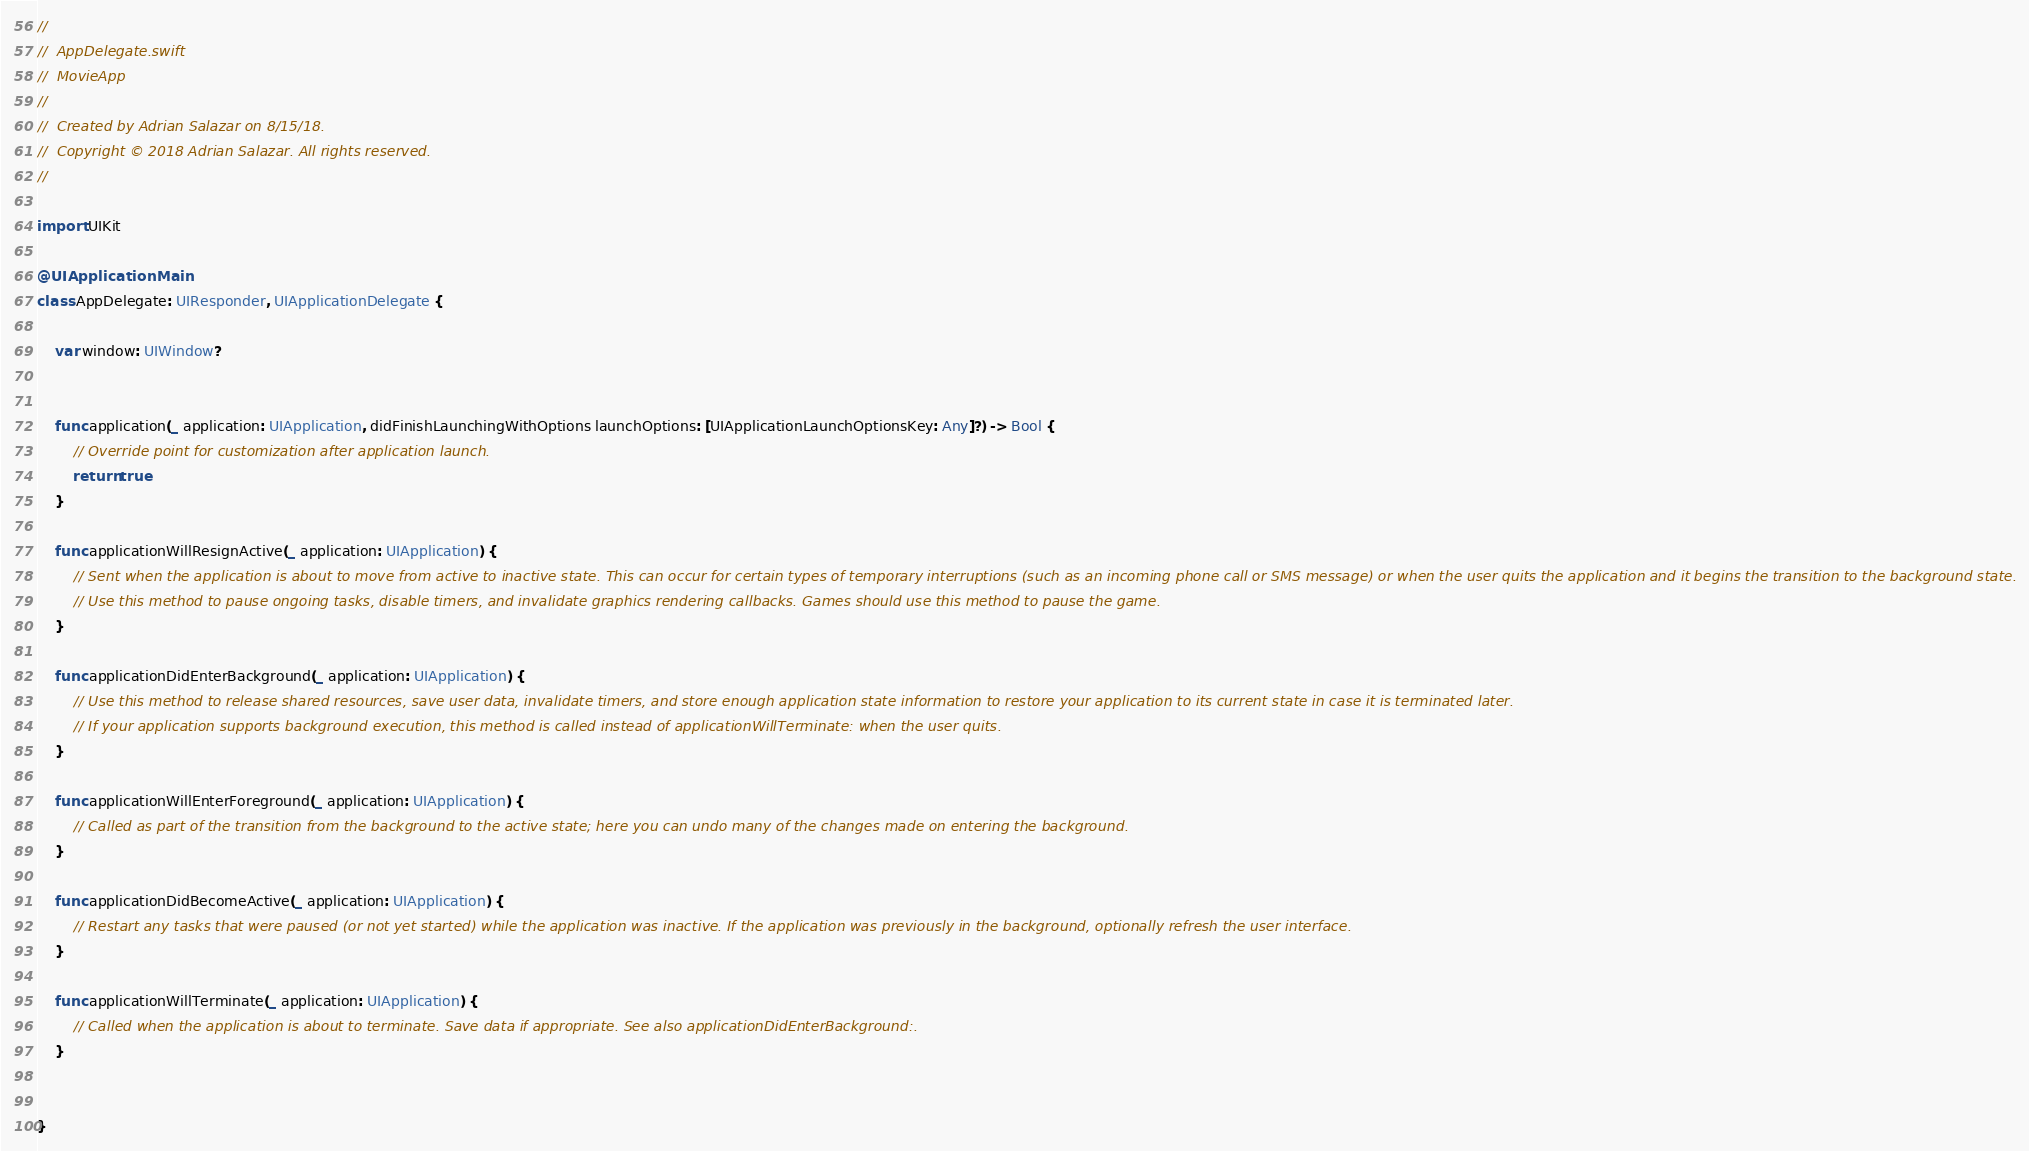Convert code to text. <code><loc_0><loc_0><loc_500><loc_500><_Swift_>//
//  AppDelegate.swift
//  MovieApp
//
//  Created by Adrian Salazar on 8/15/18.
//  Copyright © 2018 Adrian Salazar. All rights reserved.
//

import UIKit

@UIApplicationMain
class AppDelegate: UIResponder, UIApplicationDelegate {

    var window: UIWindow?


    func application(_ application: UIApplication, didFinishLaunchingWithOptions launchOptions: [UIApplicationLaunchOptionsKey: Any]?) -> Bool {
        // Override point for customization after application launch.
        return true
    }

    func applicationWillResignActive(_ application: UIApplication) {
        // Sent when the application is about to move from active to inactive state. This can occur for certain types of temporary interruptions (such as an incoming phone call or SMS message) or when the user quits the application and it begins the transition to the background state.
        // Use this method to pause ongoing tasks, disable timers, and invalidate graphics rendering callbacks. Games should use this method to pause the game.
    }

    func applicationDidEnterBackground(_ application: UIApplication) {
        // Use this method to release shared resources, save user data, invalidate timers, and store enough application state information to restore your application to its current state in case it is terminated later.
        // If your application supports background execution, this method is called instead of applicationWillTerminate: when the user quits.
    }

    func applicationWillEnterForeground(_ application: UIApplication) {
        // Called as part of the transition from the background to the active state; here you can undo many of the changes made on entering the background.
    }

    func applicationDidBecomeActive(_ application: UIApplication) {
        // Restart any tasks that were paused (or not yet started) while the application was inactive. If the application was previously in the background, optionally refresh the user interface.
    }

    func applicationWillTerminate(_ application: UIApplication) {
        // Called when the application is about to terminate. Save data if appropriate. See also applicationDidEnterBackground:.
    }


}

</code> 